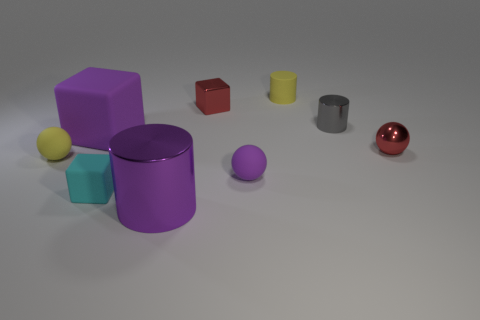Subtract all small matte blocks. How many blocks are left? 2 Add 1 big purple blocks. How many objects exist? 10 Subtract all red cubes. How many cubes are left? 2 Subtract all cylinders. How many objects are left? 6 Subtract all yellow cubes. How many green spheres are left? 0 Subtract all tiny red balls. Subtract all big purple things. How many objects are left? 6 Add 5 purple shiny objects. How many purple shiny objects are left? 6 Add 8 small blocks. How many small blocks exist? 10 Subtract 1 purple cylinders. How many objects are left? 8 Subtract 1 blocks. How many blocks are left? 2 